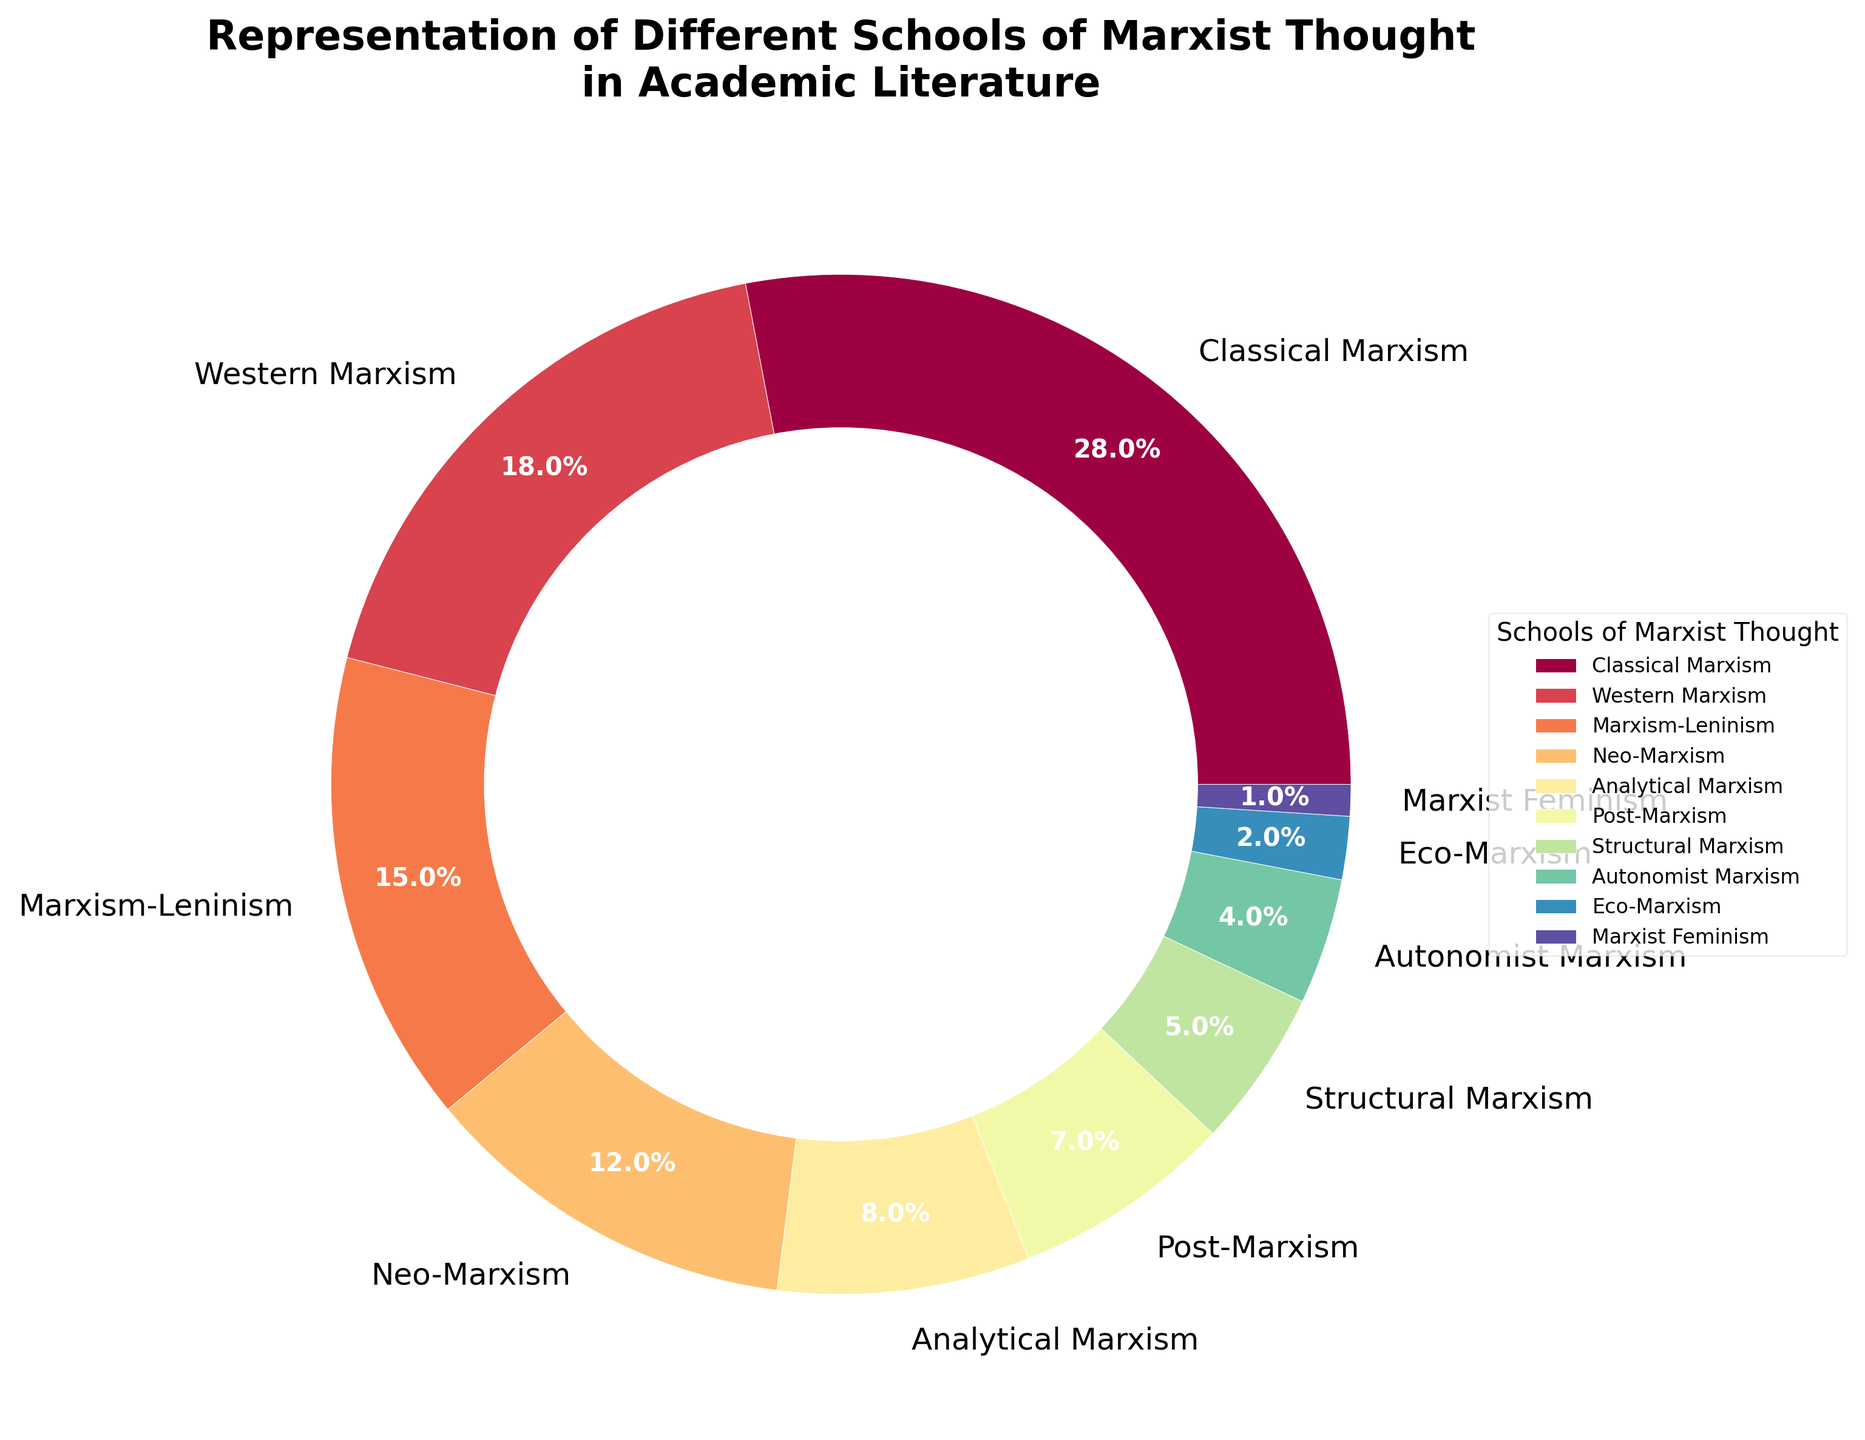What percentage of the total representation is made up of Classical Marxism and Western Marxism combined? To find the combined percentage, add the percentages of Classical Marxism (28%) and Western Marxism (18%). 28 + 18 = 46.
Answer: 46% Which school of Marxist thought has the least representation? Identifying the section of the pie chart with the smallest percentage, Marxist Feminism represents the smallest percentage at 1%.
Answer: Marxist Feminism By how much does Classical Marxism exceed Neo-Marxism in representation? Subtract the percentage of Neo-Marxism (12%) from that of Classical Marxism (28%). 28 - 12 = 16.
Answer: 16% If you combine the representations of Analytical Marxism, Post-Marxism, and Structural Marxism, what is the total percentage? Add the percentages of Analytical Marxism (8%), Post-Marxism (7%), and Structural Marxism (5%). 8 + 7 + 5 = 20.
Answer: 20% Which school of Marxist thought has a closer representation to Eco-Marxism, Post-Marxism or Analytical Marxism? Compare Eco-Marxism (2%) with Post-Marxism (7%) and Analytical Marxism (8%). The closer value would be the one with the smallest difference. 7 - 2 = 5 and 8 - 2 = 6. Hence, Post-Marxism (5%) is closer than Analytical Marxism (6%).
Answer: Post-Marxism Which two schools have the smallest combined representation, and what is their total percentage? Identify the two schools with the smallest percentages: Marxist Feminism (1%) and Eco-Marxism (2%). Add these values together. 1 + 2 = 3.
Answer: Marxist Feminism and Eco-Marxism, 3% What is the difference in representation between Western Marxism and Marxism-Leninism? Subtract the percentage of Marxism-Leninism (15%) from Western Marxism (18%). 18 - 15 = 3.
Answer: 3% How many schools of Marxist thought have a representation of 10% or more? Identify schools with 10% or more representation: Classical Marxism (28%), Western Marxism (18%), and Marxism-Leninism (15%). There are 3 such schools.
Answer: 3 Which school has a higher representation: Autonomist Marxism or Structural Marxism, and by how much? Compare the percentages of Autonomist Marxism (4%) and Structural Marxism (5%). Subtract the smaller percentage from the larger one. 5 - 4 = 1. Structural Marxism has 1% higher representation.
Answer: Structural Marxism, 1% 